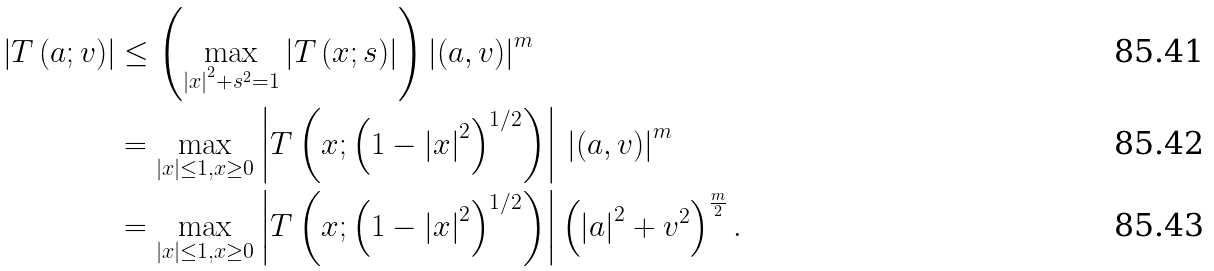Convert formula to latex. <formula><loc_0><loc_0><loc_500><loc_500>\left | T \left ( a ; v \right ) \right | & \leq \left ( \max _ { \left | x \right | ^ { 2 } + s ^ { 2 } = 1 } \left | T \left ( x ; s \right ) \right | \right ) \left | \left ( a , v \right ) \right | ^ { m } \\ & = \max _ { \left | x \right | \leq 1 , x \geq 0 } \left | T \left ( x ; \left ( 1 - \left | x \right | ^ { 2 } \right ) ^ { 1 / 2 } \right ) \right | \, \left | \left ( a , v \right ) \right | ^ { m } \\ & = \max _ { \left | x \right | \leq 1 , x \geq 0 } \left | T \left ( x ; \left ( 1 - \left | x \right | ^ { 2 } \right ) ^ { 1 / 2 } \right ) \right | \left ( \left | a \right | ^ { 2 } + v ^ { 2 } \right ) ^ { \frac { m } { 2 } } .</formula> 